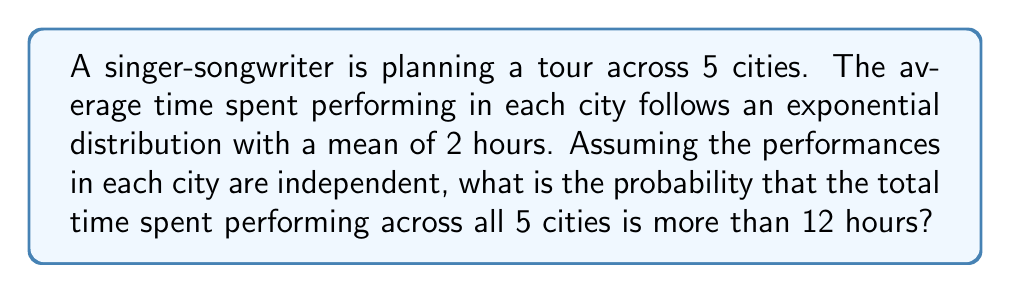Teach me how to tackle this problem. Let's approach this step-by-step:

1) First, we need to recognize that this scenario follows an Erlang distribution. The Erlang distribution describes the sum of independent exponentially distributed random variables.

2) In this case, we have:
   - Number of cities (stages) = 5
   - Mean time for each performance = 2 hours
   - Total time we're interested in = 12 hours

3) The Erlang distribution has two parameters:
   - $k$ (shape parameter) = number of stages = 5
   - $\lambda$ (rate parameter) = 1 / mean time = 1/2

4) We want to find $P(X > 12)$, where $X$ is the total time spent performing.

5) The cumulative distribution function (CDF) of the Erlang distribution is:

   $$F(x; k, \lambda) = 1 - \sum_{n=0}^{k-1} \frac{1}{n!} e^{-\lambda x} (\lambda x)^n$$

6) We need the complement of this, which is:

   $$P(X > x) = \sum_{n=0}^{k-1} \frac{1}{n!} e^{-\lambda x} (\lambda x)^n$$

7) Plugging in our values:

   $$P(X > 12) = \sum_{n=0}^{4} \frac{1}{n!} e^{-(1/2) * 12} ((1/2) * 12)^n$$

8) Simplifying:

   $$P(X > 12) = e^{-6} (1 + 6 + \frac{6^2}{2!} + \frac{6^3}{3!} + \frac{6^4}{4!})$$

9) Calculating this (you would typically use a calculator or computer for this step):

   $$P(X > 12) \approx 0.2851$$
Answer: 0.2851 